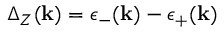Convert formula to latex. <formula><loc_0><loc_0><loc_500><loc_500>\Delta _ { Z } ( k ) = \epsilon _ { - } ( k ) - \epsilon _ { + } ( k )</formula> 